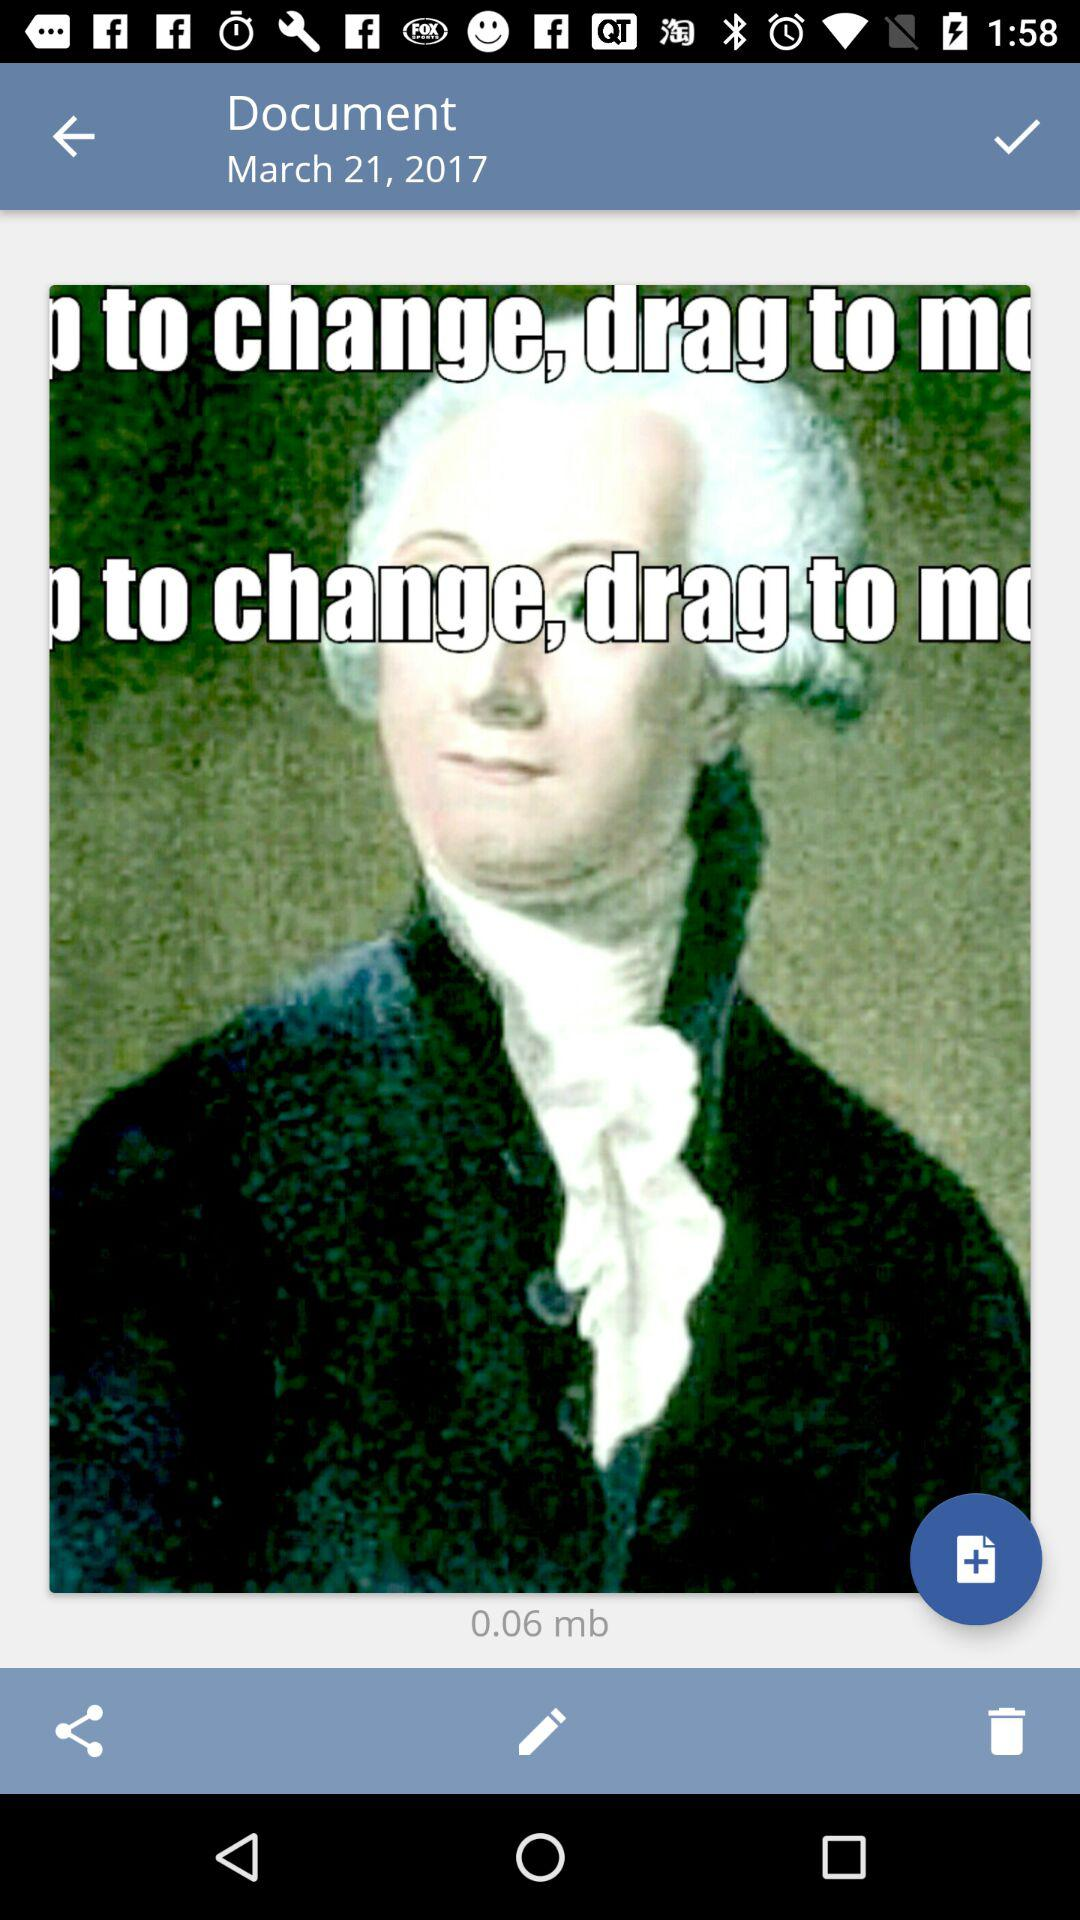What is the date? The date is March 21, 2017. 